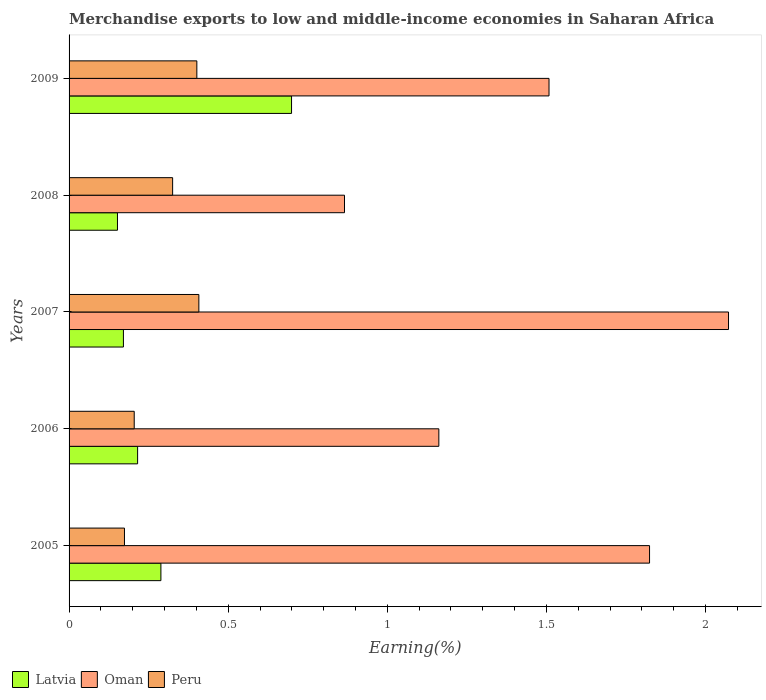How many groups of bars are there?
Give a very brief answer. 5. Are the number of bars per tick equal to the number of legend labels?
Offer a very short reply. Yes. How many bars are there on the 1st tick from the top?
Offer a very short reply. 3. In how many cases, is the number of bars for a given year not equal to the number of legend labels?
Keep it short and to the point. 0. What is the percentage of amount earned from merchandise exports in Oman in 2008?
Give a very brief answer. 0.87. Across all years, what is the maximum percentage of amount earned from merchandise exports in Peru?
Provide a succinct answer. 0.41. Across all years, what is the minimum percentage of amount earned from merchandise exports in Peru?
Provide a succinct answer. 0.17. In which year was the percentage of amount earned from merchandise exports in Oman maximum?
Your answer should be very brief. 2007. In which year was the percentage of amount earned from merchandise exports in Peru minimum?
Ensure brevity in your answer.  2005. What is the total percentage of amount earned from merchandise exports in Latvia in the graph?
Make the answer very short. 1.53. What is the difference between the percentage of amount earned from merchandise exports in Latvia in 2006 and that in 2009?
Your answer should be very brief. -0.48. What is the difference between the percentage of amount earned from merchandise exports in Latvia in 2006 and the percentage of amount earned from merchandise exports in Oman in 2005?
Make the answer very short. -1.61. What is the average percentage of amount earned from merchandise exports in Latvia per year?
Make the answer very short. 0.31. In the year 2008, what is the difference between the percentage of amount earned from merchandise exports in Latvia and percentage of amount earned from merchandise exports in Peru?
Provide a succinct answer. -0.17. In how many years, is the percentage of amount earned from merchandise exports in Latvia greater than 1.1 %?
Keep it short and to the point. 0. What is the ratio of the percentage of amount earned from merchandise exports in Peru in 2007 to that in 2009?
Offer a very short reply. 1.02. Is the difference between the percentage of amount earned from merchandise exports in Latvia in 2007 and 2009 greater than the difference between the percentage of amount earned from merchandise exports in Peru in 2007 and 2009?
Provide a succinct answer. No. What is the difference between the highest and the second highest percentage of amount earned from merchandise exports in Oman?
Offer a terse response. 0.25. What is the difference between the highest and the lowest percentage of amount earned from merchandise exports in Oman?
Make the answer very short. 1.21. Is the sum of the percentage of amount earned from merchandise exports in Latvia in 2007 and 2009 greater than the maximum percentage of amount earned from merchandise exports in Oman across all years?
Your answer should be very brief. No. What does the 2nd bar from the top in 2006 represents?
Offer a terse response. Oman. What does the 1st bar from the bottom in 2005 represents?
Provide a short and direct response. Latvia. Are all the bars in the graph horizontal?
Make the answer very short. Yes. How many years are there in the graph?
Make the answer very short. 5. Does the graph contain any zero values?
Make the answer very short. No. Does the graph contain grids?
Offer a terse response. No. Where does the legend appear in the graph?
Provide a short and direct response. Bottom left. How are the legend labels stacked?
Your answer should be very brief. Horizontal. What is the title of the graph?
Keep it short and to the point. Merchandise exports to low and middle-income economies in Saharan Africa. What is the label or title of the X-axis?
Your answer should be very brief. Earning(%). What is the Earning(%) in Latvia in 2005?
Ensure brevity in your answer.  0.29. What is the Earning(%) in Oman in 2005?
Ensure brevity in your answer.  1.82. What is the Earning(%) in Peru in 2005?
Provide a short and direct response. 0.17. What is the Earning(%) in Latvia in 2006?
Keep it short and to the point. 0.22. What is the Earning(%) in Oman in 2006?
Provide a short and direct response. 1.16. What is the Earning(%) in Peru in 2006?
Offer a terse response. 0.2. What is the Earning(%) in Latvia in 2007?
Ensure brevity in your answer.  0.17. What is the Earning(%) in Oman in 2007?
Offer a very short reply. 2.07. What is the Earning(%) in Peru in 2007?
Your response must be concise. 0.41. What is the Earning(%) of Latvia in 2008?
Keep it short and to the point. 0.15. What is the Earning(%) in Oman in 2008?
Your answer should be very brief. 0.87. What is the Earning(%) of Peru in 2008?
Your answer should be very brief. 0.33. What is the Earning(%) in Latvia in 2009?
Provide a succinct answer. 0.7. What is the Earning(%) of Oman in 2009?
Your answer should be very brief. 1.51. What is the Earning(%) in Peru in 2009?
Offer a terse response. 0.4. Across all years, what is the maximum Earning(%) of Latvia?
Offer a terse response. 0.7. Across all years, what is the maximum Earning(%) of Oman?
Keep it short and to the point. 2.07. Across all years, what is the maximum Earning(%) of Peru?
Offer a terse response. 0.41. Across all years, what is the minimum Earning(%) of Latvia?
Offer a very short reply. 0.15. Across all years, what is the minimum Earning(%) in Oman?
Ensure brevity in your answer.  0.87. Across all years, what is the minimum Earning(%) in Peru?
Your response must be concise. 0.17. What is the total Earning(%) of Latvia in the graph?
Offer a very short reply. 1.53. What is the total Earning(%) in Oman in the graph?
Provide a succinct answer. 7.43. What is the total Earning(%) of Peru in the graph?
Ensure brevity in your answer.  1.51. What is the difference between the Earning(%) in Latvia in 2005 and that in 2006?
Keep it short and to the point. 0.07. What is the difference between the Earning(%) of Oman in 2005 and that in 2006?
Make the answer very short. 0.66. What is the difference between the Earning(%) of Peru in 2005 and that in 2006?
Offer a very short reply. -0.03. What is the difference between the Earning(%) of Latvia in 2005 and that in 2007?
Your answer should be very brief. 0.12. What is the difference between the Earning(%) in Oman in 2005 and that in 2007?
Offer a terse response. -0.25. What is the difference between the Earning(%) of Peru in 2005 and that in 2007?
Give a very brief answer. -0.23. What is the difference between the Earning(%) of Latvia in 2005 and that in 2008?
Provide a short and direct response. 0.14. What is the difference between the Earning(%) in Oman in 2005 and that in 2008?
Provide a succinct answer. 0.96. What is the difference between the Earning(%) of Peru in 2005 and that in 2008?
Keep it short and to the point. -0.15. What is the difference between the Earning(%) in Latvia in 2005 and that in 2009?
Provide a succinct answer. -0.41. What is the difference between the Earning(%) of Oman in 2005 and that in 2009?
Your answer should be compact. 0.32. What is the difference between the Earning(%) of Peru in 2005 and that in 2009?
Give a very brief answer. -0.23. What is the difference between the Earning(%) of Latvia in 2006 and that in 2007?
Keep it short and to the point. 0.04. What is the difference between the Earning(%) of Oman in 2006 and that in 2007?
Give a very brief answer. -0.91. What is the difference between the Earning(%) in Peru in 2006 and that in 2007?
Provide a short and direct response. -0.2. What is the difference between the Earning(%) in Latvia in 2006 and that in 2008?
Your response must be concise. 0.06. What is the difference between the Earning(%) of Oman in 2006 and that in 2008?
Give a very brief answer. 0.3. What is the difference between the Earning(%) in Peru in 2006 and that in 2008?
Give a very brief answer. -0.12. What is the difference between the Earning(%) of Latvia in 2006 and that in 2009?
Your answer should be very brief. -0.48. What is the difference between the Earning(%) in Oman in 2006 and that in 2009?
Your answer should be compact. -0.35. What is the difference between the Earning(%) of Peru in 2006 and that in 2009?
Offer a terse response. -0.2. What is the difference between the Earning(%) of Latvia in 2007 and that in 2008?
Keep it short and to the point. 0.02. What is the difference between the Earning(%) of Oman in 2007 and that in 2008?
Offer a very short reply. 1.21. What is the difference between the Earning(%) of Peru in 2007 and that in 2008?
Provide a short and direct response. 0.08. What is the difference between the Earning(%) of Latvia in 2007 and that in 2009?
Provide a short and direct response. -0.53. What is the difference between the Earning(%) of Oman in 2007 and that in 2009?
Ensure brevity in your answer.  0.56. What is the difference between the Earning(%) in Peru in 2007 and that in 2009?
Give a very brief answer. 0.01. What is the difference between the Earning(%) of Latvia in 2008 and that in 2009?
Give a very brief answer. -0.55. What is the difference between the Earning(%) of Oman in 2008 and that in 2009?
Your answer should be compact. -0.64. What is the difference between the Earning(%) of Peru in 2008 and that in 2009?
Your answer should be very brief. -0.08. What is the difference between the Earning(%) in Latvia in 2005 and the Earning(%) in Oman in 2006?
Offer a very short reply. -0.87. What is the difference between the Earning(%) in Latvia in 2005 and the Earning(%) in Peru in 2006?
Provide a succinct answer. 0.08. What is the difference between the Earning(%) in Oman in 2005 and the Earning(%) in Peru in 2006?
Provide a short and direct response. 1.62. What is the difference between the Earning(%) in Latvia in 2005 and the Earning(%) in Oman in 2007?
Provide a succinct answer. -1.78. What is the difference between the Earning(%) of Latvia in 2005 and the Earning(%) of Peru in 2007?
Your answer should be compact. -0.12. What is the difference between the Earning(%) of Oman in 2005 and the Earning(%) of Peru in 2007?
Provide a succinct answer. 1.42. What is the difference between the Earning(%) of Latvia in 2005 and the Earning(%) of Oman in 2008?
Offer a very short reply. -0.58. What is the difference between the Earning(%) of Latvia in 2005 and the Earning(%) of Peru in 2008?
Ensure brevity in your answer.  -0.04. What is the difference between the Earning(%) of Oman in 2005 and the Earning(%) of Peru in 2008?
Ensure brevity in your answer.  1.5. What is the difference between the Earning(%) of Latvia in 2005 and the Earning(%) of Oman in 2009?
Your answer should be compact. -1.22. What is the difference between the Earning(%) in Latvia in 2005 and the Earning(%) in Peru in 2009?
Your answer should be compact. -0.11. What is the difference between the Earning(%) in Oman in 2005 and the Earning(%) in Peru in 2009?
Make the answer very short. 1.42. What is the difference between the Earning(%) of Latvia in 2006 and the Earning(%) of Oman in 2007?
Offer a terse response. -1.86. What is the difference between the Earning(%) in Latvia in 2006 and the Earning(%) in Peru in 2007?
Your answer should be very brief. -0.19. What is the difference between the Earning(%) of Oman in 2006 and the Earning(%) of Peru in 2007?
Your response must be concise. 0.75. What is the difference between the Earning(%) of Latvia in 2006 and the Earning(%) of Oman in 2008?
Ensure brevity in your answer.  -0.65. What is the difference between the Earning(%) of Latvia in 2006 and the Earning(%) of Peru in 2008?
Your answer should be compact. -0.11. What is the difference between the Earning(%) in Oman in 2006 and the Earning(%) in Peru in 2008?
Keep it short and to the point. 0.84. What is the difference between the Earning(%) in Latvia in 2006 and the Earning(%) in Oman in 2009?
Offer a very short reply. -1.29. What is the difference between the Earning(%) of Latvia in 2006 and the Earning(%) of Peru in 2009?
Your response must be concise. -0.19. What is the difference between the Earning(%) in Oman in 2006 and the Earning(%) in Peru in 2009?
Keep it short and to the point. 0.76. What is the difference between the Earning(%) in Latvia in 2007 and the Earning(%) in Oman in 2008?
Your response must be concise. -0.69. What is the difference between the Earning(%) in Latvia in 2007 and the Earning(%) in Peru in 2008?
Provide a succinct answer. -0.15. What is the difference between the Earning(%) in Oman in 2007 and the Earning(%) in Peru in 2008?
Your answer should be very brief. 1.75. What is the difference between the Earning(%) in Latvia in 2007 and the Earning(%) in Oman in 2009?
Offer a very short reply. -1.34. What is the difference between the Earning(%) in Latvia in 2007 and the Earning(%) in Peru in 2009?
Your answer should be very brief. -0.23. What is the difference between the Earning(%) in Oman in 2007 and the Earning(%) in Peru in 2009?
Provide a short and direct response. 1.67. What is the difference between the Earning(%) in Latvia in 2008 and the Earning(%) in Oman in 2009?
Make the answer very short. -1.36. What is the difference between the Earning(%) in Latvia in 2008 and the Earning(%) in Peru in 2009?
Provide a succinct answer. -0.25. What is the difference between the Earning(%) of Oman in 2008 and the Earning(%) of Peru in 2009?
Provide a succinct answer. 0.46. What is the average Earning(%) in Latvia per year?
Your answer should be very brief. 0.31. What is the average Earning(%) of Oman per year?
Provide a succinct answer. 1.49. What is the average Earning(%) of Peru per year?
Give a very brief answer. 0.3. In the year 2005, what is the difference between the Earning(%) of Latvia and Earning(%) of Oman?
Ensure brevity in your answer.  -1.54. In the year 2005, what is the difference between the Earning(%) in Latvia and Earning(%) in Peru?
Provide a succinct answer. 0.11. In the year 2005, what is the difference between the Earning(%) of Oman and Earning(%) of Peru?
Your response must be concise. 1.65. In the year 2006, what is the difference between the Earning(%) of Latvia and Earning(%) of Oman?
Your answer should be very brief. -0.95. In the year 2006, what is the difference between the Earning(%) of Latvia and Earning(%) of Peru?
Offer a terse response. 0.01. In the year 2006, what is the difference between the Earning(%) in Oman and Earning(%) in Peru?
Provide a short and direct response. 0.96. In the year 2007, what is the difference between the Earning(%) of Latvia and Earning(%) of Oman?
Give a very brief answer. -1.9. In the year 2007, what is the difference between the Earning(%) in Latvia and Earning(%) in Peru?
Your answer should be very brief. -0.24. In the year 2007, what is the difference between the Earning(%) of Oman and Earning(%) of Peru?
Keep it short and to the point. 1.66. In the year 2008, what is the difference between the Earning(%) of Latvia and Earning(%) of Oman?
Keep it short and to the point. -0.71. In the year 2008, what is the difference between the Earning(%) in Latvia and Earning(%) in Peru?
Keep it short and to the point. -0.17. In the year 2008, what is the difference between the Earning(%) in Oman and Earning(%) in Peru?
Keep it short and to the point. 0.54. In the year 2009, what is the difference between the Earning(%) in Latvia and Earning(%) in Oman?
Keep it short and to the point. -0.81. In the year 2009, what is the difference between the Earning(%) of Latvia and Earning(%) of Peru?
Provide a succinct answer. 0.3. In the year 2009, what is the difference between the Earning(%) of Oman and Earning(%) of Peru?
Provide a short and direct response. 1.11. What is the ratio of the Earning(%) in Latvia in 2005 to that in 2006?
Ensure brevity in your answer.  1.34. What is the ratio of the Earning(%) in Oman in 2005 to that in 2006?
Provide a succinct answer. 1.57. What is the ratio of the Earning(%) in Peru in 2005 to that in 2006?
Your response must be concise. 0.85. What is the ratio of the Earning(%) of Latvia in 2005 to that in 2007?
Your response must be concise. 1.69. What is the ratio of the Earning(%) of Oman in 2005 to that in 2007?
Keep it short and to the point. 0.88. What is the ratio of the Earning(%) of Peru in 2005 to that in 2007?
Keep it short and to the point. 0.43. What is the ratio of the Earning(%) of Latvia in 2005 to that in 2008?
Your answer should be compact. 1.9. What is the ratio of the Earning(%) in Oman in 2005 to that in 2008?
Your answer should be very brief. 2.11. What is the ratio of the Earning(%) of Peru in 2005 to that in 2008?
Make the answer very short. 0.54. What is the ratio of the Earning(%) of Latvia in 2005 to that in 2009?
Offer a terse response. 0.41. What is the ratio of the Earning(%) in Oman in 2005 to that in 2009?
Make the answer very short. 1.21. What is the ratio of the Earning(%) in Peru in 2005 to that in 2009?
Make the answer very short. 0.43. What is the ratio of the Earning(%) of Latvia in 2006 to that in 2007?
Offer a terse response. 1.26. What is the ratio of the Earning(%) in Oman in 2006 to that in 2007?
Ensure brevity in your answer.  0.56. What is the ratio of the Earning(%) in Peru in 2006 to that in 2007?
Your response must be concise. 0.5. What is the ratio of the Earning(%) of Latvia in 2006 to that in 2008?
Provide a short and direct response. 1.42. What is the ratio of the Earning(%) of Oman in 2006 to that in 2008?
Make the answer very short. 1.34. What is the ratio of the Earning(%) of Peru in 2006 to that in 2008?
Ensure brevity in your answer.  0.63. What is the ratio of the Earning(%) of Latvia in 2006 to that in 2009?
Your answer should be very brief. 0.31. What is the ratio of the Earning(%) of Oman in 2006 to that in 2009?
Ensure brevity in your answer.  0.77. What is the ratio of the Earning(%) in Peru in 2006 to that in 2009?
Your answer should be compact. 0.51. What is the ratio of the Earning(%) of Latvia in 2007 to that in 2008?
Offer a terse response. 1.12. What is the ratio of the Earning(%) in Oman in 2007 to that in 2008?
Offer a very short reply. 2.39. What is the ratio of the Earning(%) in Peru in 2007 to that in 2008?
Provide a succinct answer. 1.25. What is the ratio of the Earning(%) in Latvia in 2007 to that in 2009?
Keep it short and to the point. 0.24. What is the ratio of the Earning(%) of Oman in 2007 to that in 2009?
Your answer should be compact. 1.37. What is the ratio of the Earning(%) in Peru in 2007 to that in 2009?
Ensure brevity in your answer.  1.02. What is the ratio of the Earning(%) of Latvia in 2008 to that in 2009?
Your answer should be very brief. 0.22. What is the ratio of the Earning(%) in Oman in 2008 to that in 2009?
Ensure brevity in your answer.  0.57. What is the ratio of the Earning(%) in Peru in 2008 to that in 2009?
Your response must be concise. 0.81. What is the difference between the highest and the second highest Earning(%) of Latvia?
Your response must be concise. 0.41. What is the difference between the highest and the second highest Earning(%) in Oman?
Give a very brief answer. 0.25. What is the difference between the highest and the second highest Earning(%) of Peru?
Make the answer very short. 0.01. What is the difference between the highest and the lowest Earning(%) of Latvia?
Your answer should be very brief. 0.55. What is the difference between the highest and the lowest Earning(%) of Oman?
Your answer should be compact. 1.21. What is the difference between the highest and the lowest Earning(%) in Peru?
Make the answer very short. 0.23. 